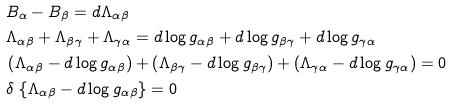Convert formula to latex. <formula><loc_0><loc_0><loc_500><loc_500>& B _ { \alpha } - B _ { \beta } = d \Lambda _ { \alpha \beta } \\ & \Lambda _ { \alpha \beta } + \Lambda _ { \beta \gamma } + \Lambda _ { \gamma \alpha } = d \log g _ { \alpha \beta } + d \log g _ { \beta \gamma } + d \log g _ { \gamma \alpha } \\ & \left ( \Lambda _ { \alpha \beta } - d \log g _ { \alpha \beta } \right ) + \left ( \Lambda _ { \beta \gamma } - d \log g _ { \beta \gamma } \right ) + \left ( \Lambda _ { \gamma \alpha } - d \log g _ { \gamma \alpha } \right ) = 0 \\ & \delta \, \left \{ \Lambda _ { \alpha \beta } - d \log g _ { \alpha \beta } \right \} = 0</formula> 